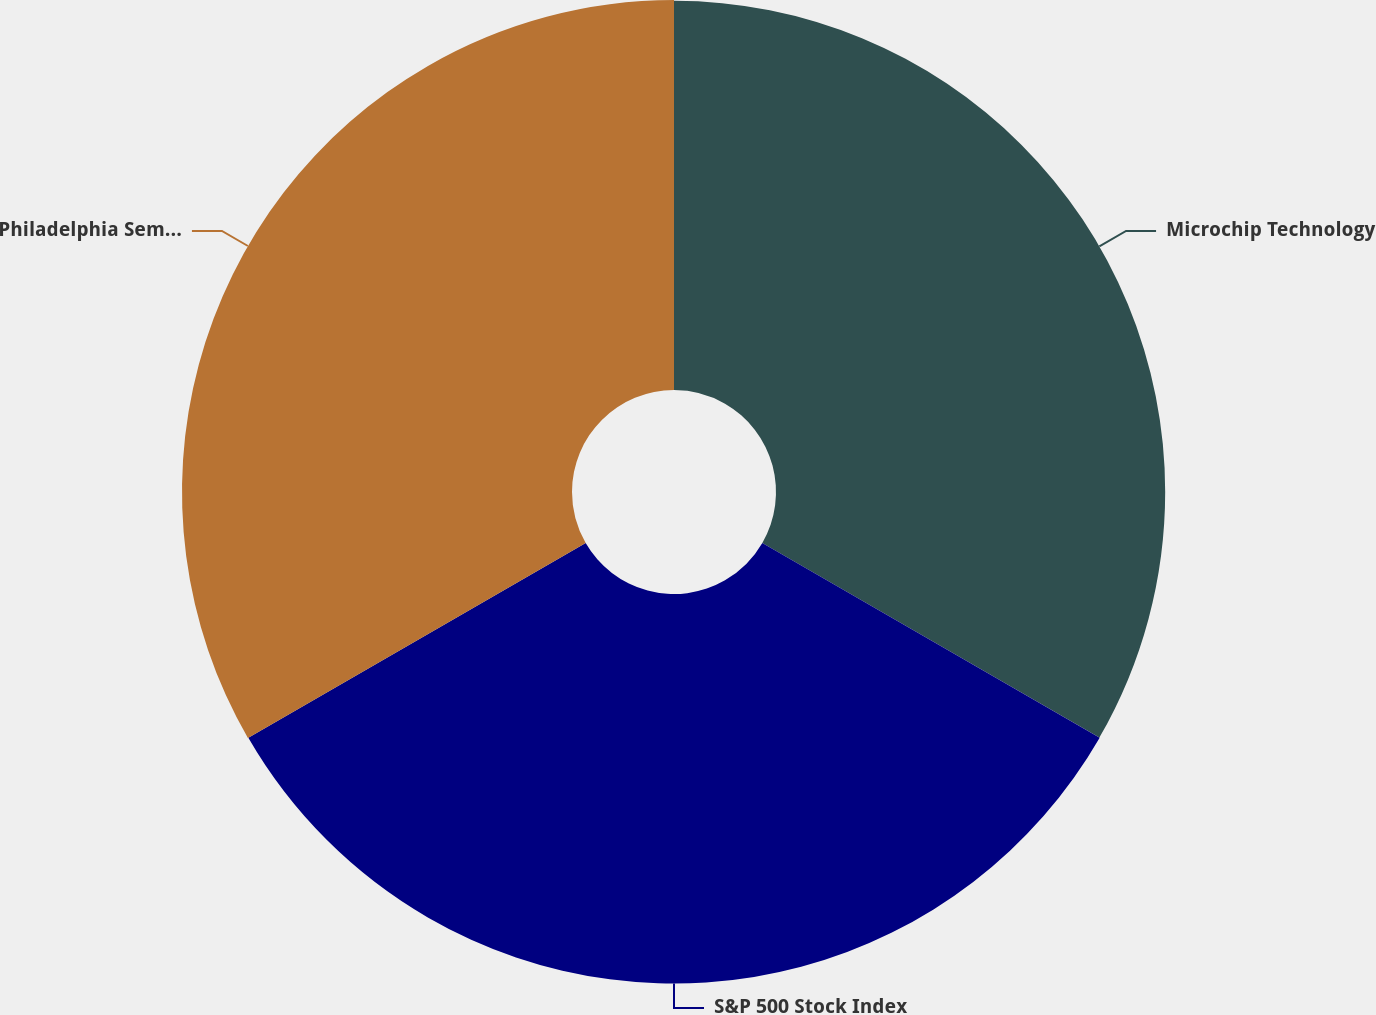Convert chart. <chart><loc_0><loc_0><loc_500><loc_500><pie_chart><fcel>Microchip Technology<fcel>S&P 500 Stock Index<fcel>Philadelphia Semiconductor<nl><fcel>33.3%<fcel>33.33%<fcel>33.37%<nl></chart> 